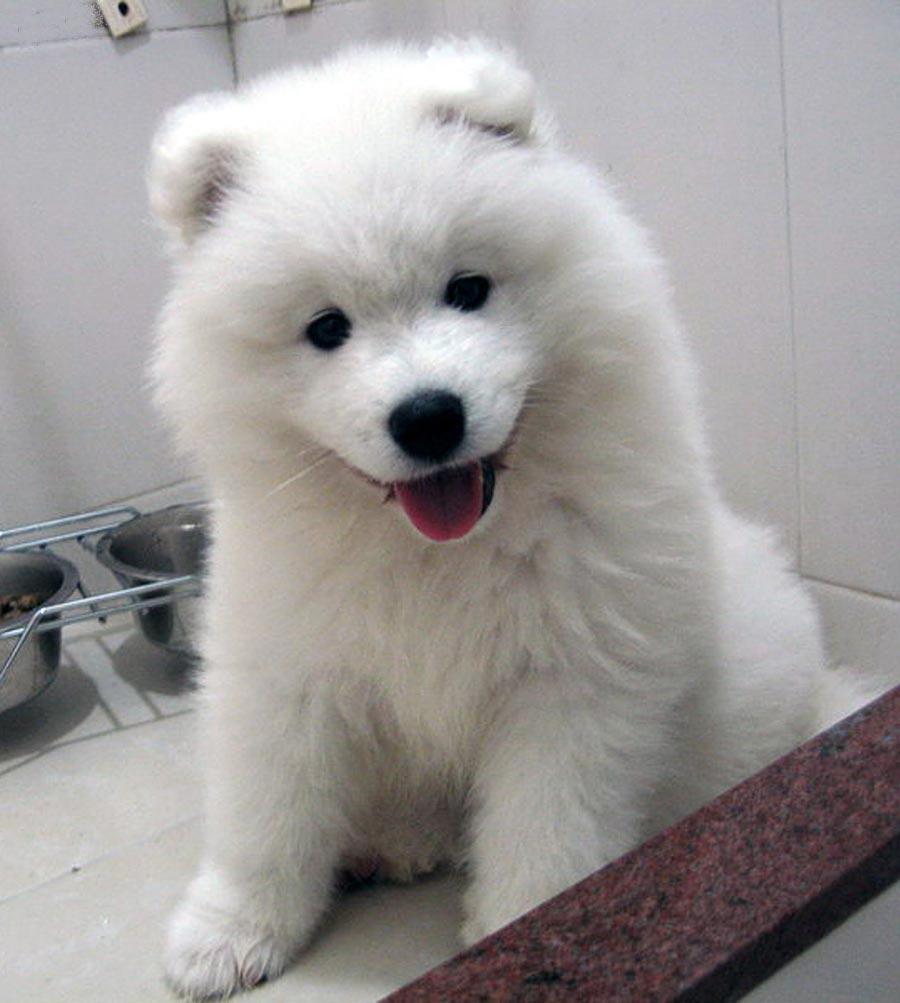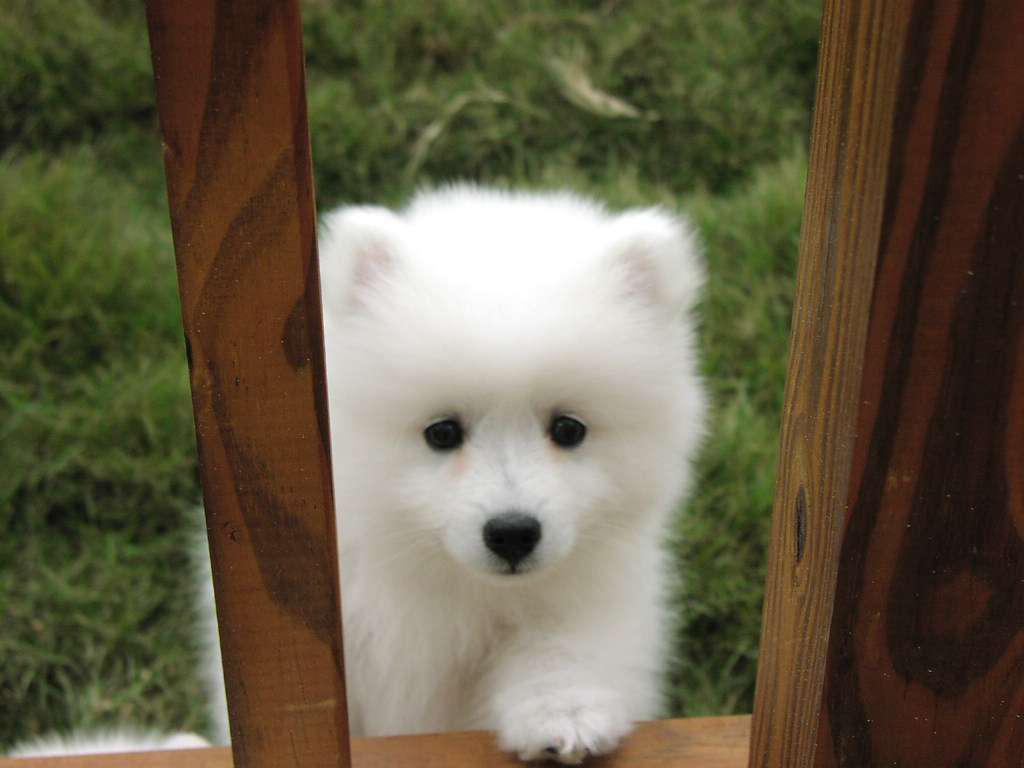The first image is the image on the left, the second image is the image on the right. For the images displayed, is the sentence "There are at most two dogs." factually correct? Answer yes or no. Yes. The first image is the image on the left, the second image is the image on the right. Evaluate the accuracy of this statement regarding the images: "One image contains twice as many white puppies as the other image and features puppies with their heads touching.". Is it true? Answer yes or no. No. 